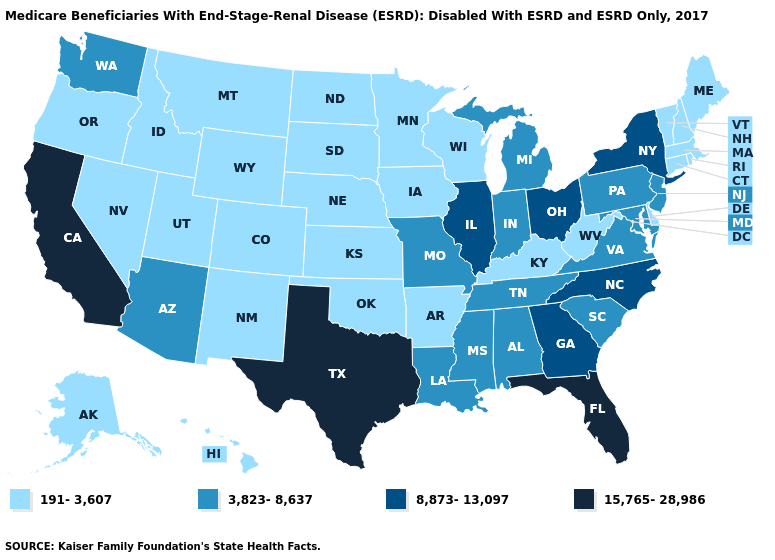Does Hawaii have the lowest value in the West?
Answer briefly. Yes. Name the states that have a value in the range 191-3,607?
Short answer required. Alaska, Arkansas, Colorado, Connecticut, Delaware, Hawaii, Idaho, Iowa, Kansas, Kentucky, Maine, Massachusetts, Minnesota, Montana, Nebraska, Nevada, New Hampshire, New Mexico, North Dakota, Oklahoma, Oregon, Rhode Island, South Dakota, Utah, Vermont, West Virginia, Wisconsin, Wyoming. What is the value of Colorado?
Short answer required. 191-3,607. Does Washington have the lowest value in the West?
Be succinct. No. Name the states that have a value in the range 3,823-8,637?
Write a very short answer. Alabama, Arizona, Indiana, Louisiana, Maryland, Michigan, Mississippi, Missouri, New Jersey, Pennsylvania, South Carolina, Tennessee, Virginia, Washington. What is the value of Arizona?
Keep it brief. 3,823-8,637. Does the map have missing data?
Give a very brief answer. No. What is the value of Indiana?
Write a very short answer. 3,823-8,637. Does Missouri have the lowest value in the USA?
Be succinct. No. What is the highest value in states that border Maryland?
Be succinct. 3,823-8,637. Does Virginia have the lowest value in the USA?
Be succinct. No. Among the states that border Massachusetts , which have the lowest value?
Be succinct. Connecticut, New Hampshire, Rhode Island, Vermont. Which states have the highest value in the USA?
Quick response, please. California, Florida, Texas. Does the first symbol in the legend represent the smallest category?
Keep it brief. Yes. Does the map have missing data?
Be succinct. No. 